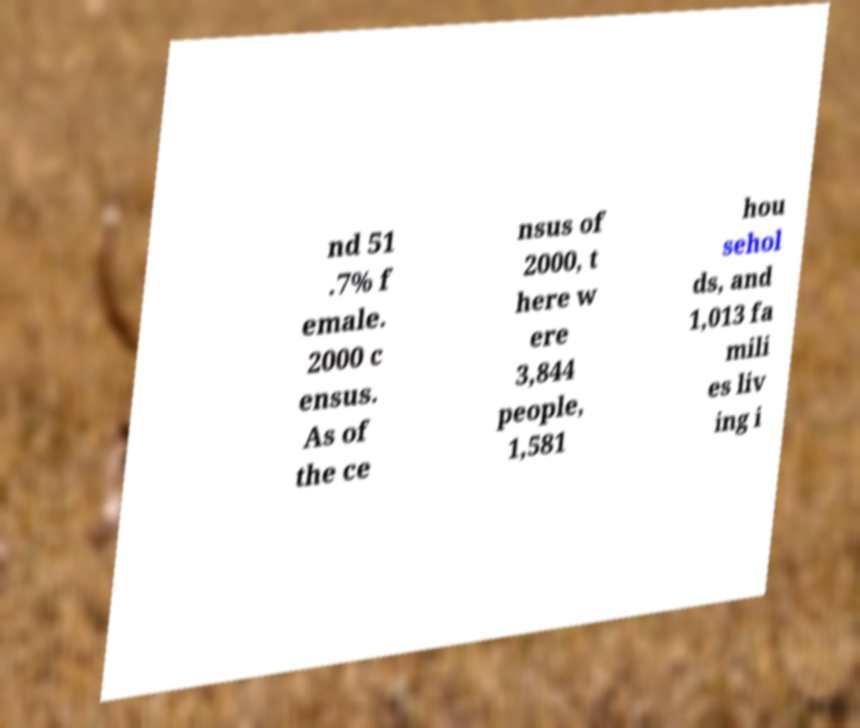Can you read and provide the text displayed in the image?This photo seems to have some interesting text. Can you extract and type it out for me? nd 51 .7% f emale. 2000 c ensus. As of the ce nsus of 2000, t here w ere 3,844 people, 1,581 hou sehol ds, and 1,013 fa mili es liv ing i 